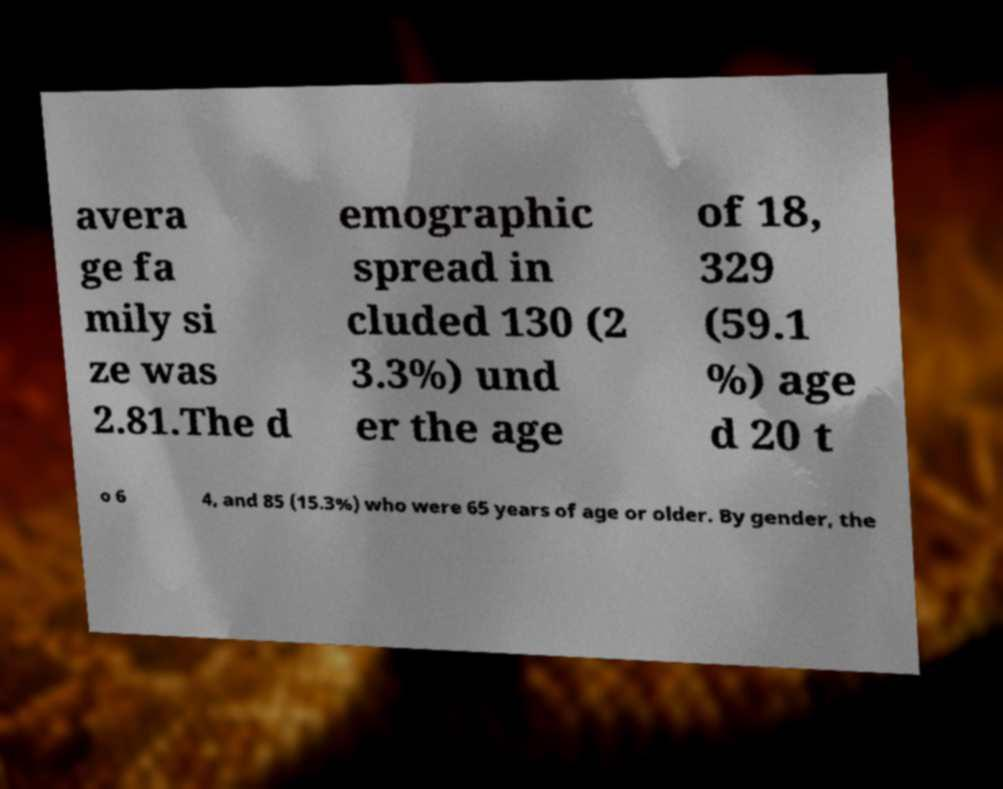Please identify and transcribe the text found in this image. avera ge fa mily si ze was 2.81.The d emographic spread in cluded 130 (2 3.3%) und er the age of 18, 329 (59.1 %) age d 20 t o 6 4, and 85 (15.3%) who were 65 years of age or older. By gender, the 